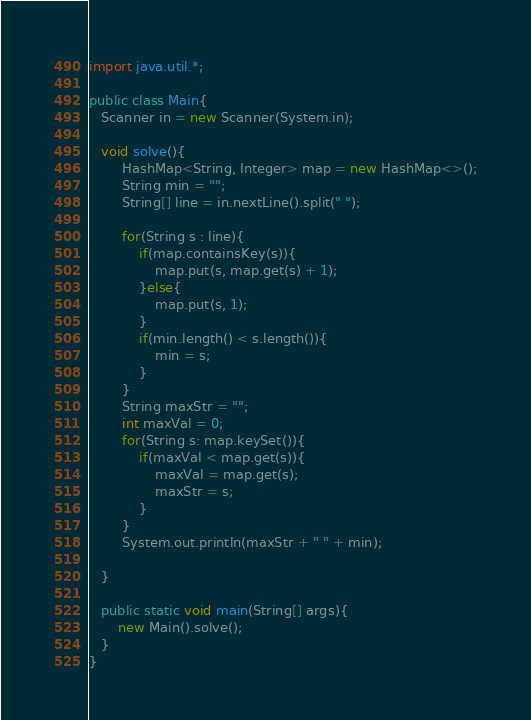<code> <loc_0><loc_0><loc_500><loc_500><_Java_>import java.util.*;

public class Main{
   Scanner in = new Scanner(System.in);

   void solve(){
        HashMap<String, Integer> map = new HashMap<>();
        String min = "";
        String[] line = in.nextLine().split(" ");

        for(String s : line){
            if(map.containsKey(s)){
                map.put(s, map.get(s) + 1);
            }else{
                map.put(s, 1);
            }
            if(min.length() < s.length()){
                min = s;
            }
        }
        String maxStr = "";
        int maxVal = 0;
        for(String s: map.keySet()){
            if(maxVal < map.get(s)){
                maxVal = map.get(s);
                maxStr = s;
            }
        }
        System.out.println(maxStr + " " + min);
        
   }

   public static void main(String[] args){
       new Main().solve();    
   }
}</code> 